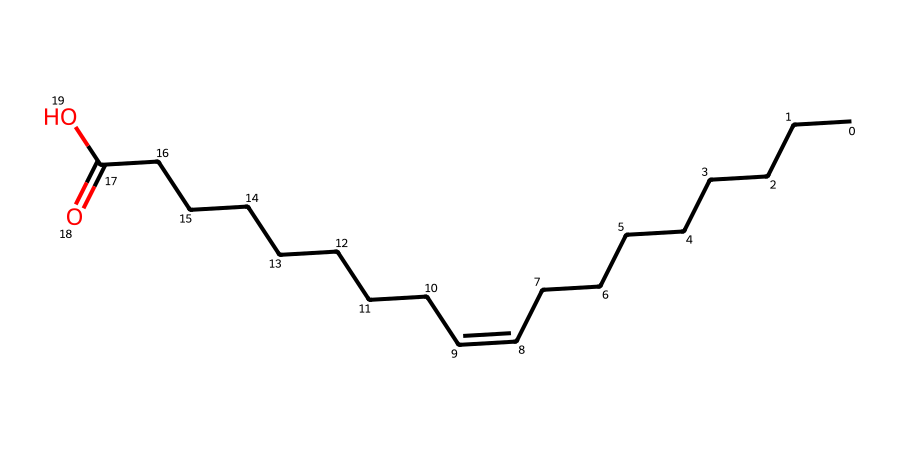What is the chemical name of the first molecule? The first molecule has the structure of oleic acid, which has a cis double bond configuration.
Answer: oleic acid What is the chemical name of the second molecule? The second molecule has the structure of elaidic acid, which features a trans double bond configuration.
Answer: elaidic acid How many carbon atoms are present in both molecules? Both oleic acid and elaidic acid have 18 carbon atoms in their structure, as indicated by the chain length in the SMILES representation.
Answer: 18 What type of isomerism is exhibited by these molecules? The two molecules (oleic and elaidic acids) are geometric isomers due to the different orientations of the double bond, either cis or trans.
Answer: geometric isomers Which fatty acid is more likely to be found in cooking oils? Oleic acid is more prevalent in cooking oils as it is typically found in healthier oils like olive oil.
Answer: oleic acid What effect does the double bond configuration have on melting point? The cis configuration of oleic acid generally leads to a lower melting point compared to the trans configuration of elaidic acid, which tends to have a higher melting point.
Answer: lower melting point What is the effect of these isomers on human health? Cis fatty acids (oleic acid) are generally considered healthier, while trans fatty acids (elaidic acid) are associated with negative health effects.
Answer: negative health effects 